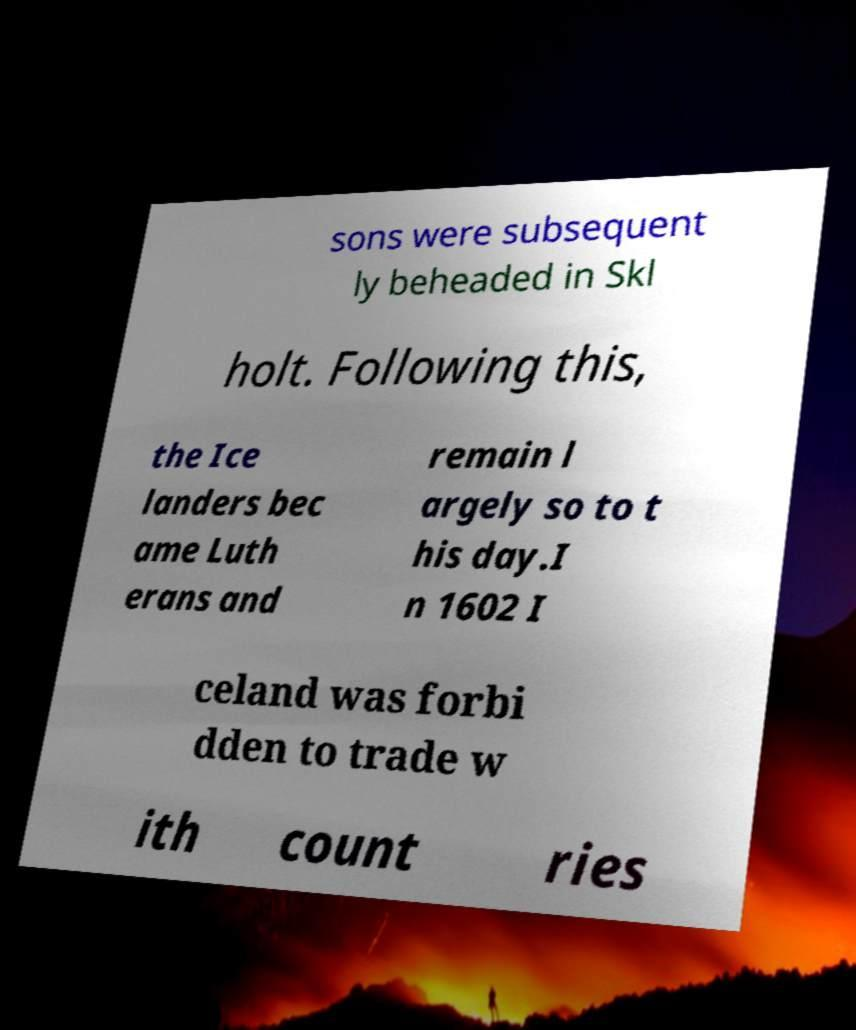Can you read and provide the text displayed in the image?This photo seems to have some interesting text. Can you extract and type it out for me? sons were subsequent ly beheaded in Skl holt. Following this, the Ice landers bec ame Luth erans and remain l argely so to t his day.I n 1602 I celand was forbi dden to trade w ith count ries 